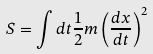<formula> <loc_0><loc_0><loc_500><loc_500>S = \int d t \frac { 1 } { 2 } m \left ( \frac { d x } { d t } \right ) ^ { 2 }</formula> 